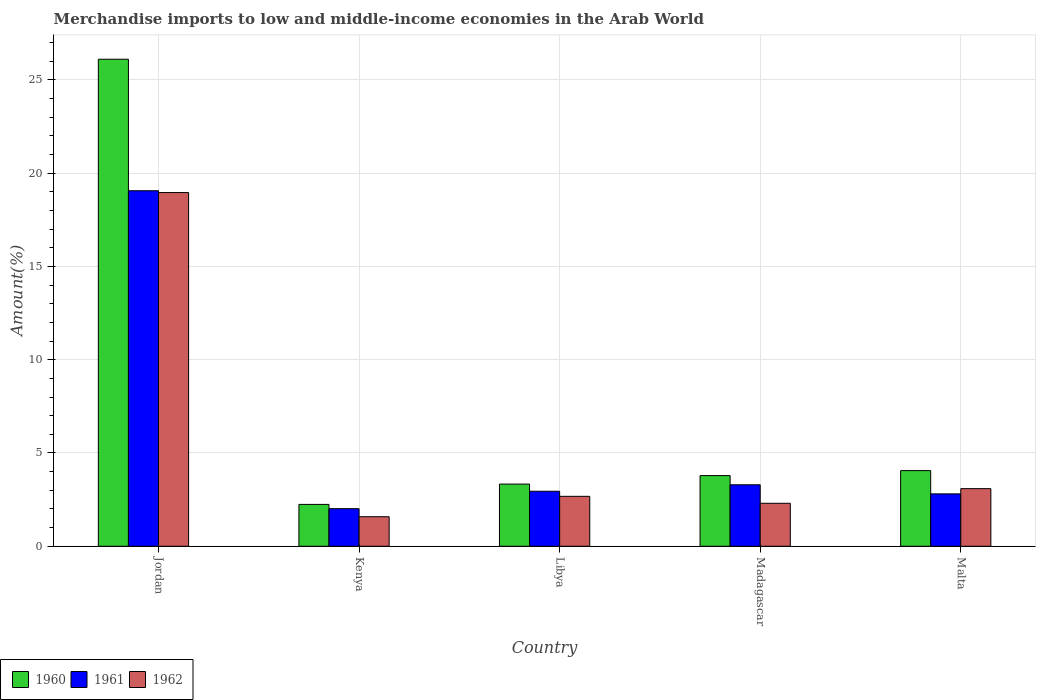Are the number of bars per tick equal to the number of legend labels?
Make the answer very short. Yes. Are the number of bars on each tick of the X-axis equal?
Your response must be concise. Yes. What is the label of the 3rd group of bars from the left?
Offer a very short reply. Libya. In how many cases, is the number of bars for a given country not equal to the number of legend labels?
Make the answer very short. 0. What is the percentage of amount earned from merchandise imports in 1961 in Madagascar?
Offer a terse response. 3.29. Across all countries, what is the maximum percentage of amount earned from merchandise imports in 1961?
Provide a short and direct response. 19.06. Across all countries, what is the minimum percentage of amount earned from merchandise imports in 1962?
Keep it short and to the point. 1.58. In which country was the percentage of amount earned from merchandise imports in 1960 maximum?
Your answer should be compact. Jordan. In which country was the percentage of amount earned from merchandise imports in 1960 minimum?
Provide a short and direct response. Kenya. What is the total percentage of amount earned from merchandise imports in 1962 in the graph?
Your response must be concise. 28.61. What is the difference between the percentage of amount earned from merchandise imports in 1962 in Madagascar and that in Malta?
Your answer should be very brief. -0.78. What is the difference between the percentage of amount earned from merchandise imports in 1962 in Malta and the percentage of amount earned from merchandise imports in 1961 in Jordan?
Give a very brief answer. -15.97. What is the average percentage of amount earned from merchandise imports in 1960 per country?
Your answer should be very brief. 7.9. What is the difference between the percentage of amount earned from merchandise imports of/in 1960 and percentage of amount earned from merchandise imports of/in 1961 in Kenya?
Ensure brevity in your answer.  0.23. What is the ratio of the percentage of amount earned from merchandise imports in 1961 in Jordan to that in Kenya?
Keep it short and to the point. 9.46. Is the difference between the percentage of amount earned from merchandise imports in 1960 in Madagascar and Malta greater than the difference between the percentage of amount earned from merchandise imports in 1961 in Madagascar and Malta?
Ensure brevity in your answer.  No. What is the difference between the highest and the second highest percentage of amount earned from merchandise imports in 1961?
Your answer should be very brief. 0.35. What is the difference between the highest and the lowest percentage of amount earned from merchandise imports in 1960?
Keep it short and to the point. 23.86. How many countries are there in the graph?
Your answer should be compact. 5. Does the graph contain grids?
Offer a terse response. Yes. Where does the legend appear in the graph?
Your answer should be compact. Bottom left. How are the legend labels stacked?
Provide a succinct answer. Horizontal. What is the title of the graph?
Offer a very short reply. Merchandise imports to low and middle-income economies in the Arab World. Does "1976" appear as one of the legend labels in the graph?
Provide a short and direct response. No. What is the label or title of the Y-axis?
Your response must be concise. Amount(%). What is the Amount(%) of 1960 in Jordan?
Give a very brief answer. 26.11. What is the Amount(%) of 1961 in Jordan?
Offer a terse response. 19.06. What is the Amount(%) in 1962 in Jordan?
Your answer should be very brief. 18.96. What is the Amount(%) of 1960 in Kenya?
Your response must be concise. 2.24. What is the Amount(%) of 1961 in Kenya?
Keep it short and to the point. 2.01. What is the Amount(%) in 1962 in Kenya?
Offer a very short reply. 1.58. What is the Amount(%) in 1960 in Libya?
Your answer should be very brief. 3.33. What is the Amount(%) in 1961 in Libya?
Your response must be concise. 2.95. What is the Amount(%) of 1962 in Libya?
Offer a terse response. 2.68. What is the Amount(%) in 1960 in Madagascar?
Give a very brief answer. 3.79. What is the Amount(%) of 1961 in Madagascar?
Offer a very short reply. 3.29. What is the Amount(%) in 1962 in Madagascar?
Provide a short and direct response. 2.3. What is the Amount(%) in 1960 in Malta?
Keep it short and to the point. 4.06. What is the Amount(%) of 1961 in Malta?
Ensure brevity in your answer.  2.81. What is the Amount(%) of 1962 in Malta?
Offer a very short reply. 3.09. Across all countries, what is the maximum Amount(%) of 1960?
Keep it short and to the point. 26.11. Across all countries, what is the maximum Amount(%) in 1961?
Your response must be concise. 19.06. Across all countries, what is the maximum Amount(%) of 1962?
Your answer should be very brief. 18.96. Across all countries, what is the minimum Amount(%) of 1960?
Your answer should be compact. 2.24. Across all countries, what is the minimum Amount(%) in 1961?
Offer a terse response. 2.01. Across all countries, what is the minimum Amount(%) of 1962?
Your answer should be compact. 1.58. What is the total Amount(%) in 1960 in the graph?
Provide a succinct answer. 39.52. What is the total Amount(%) in 1961 in the graph?
Provide a succinct answer. 30.12. What is the total Amount(%) in 1962 in the graph?
Keep it short and to the point. 28.61. What is the difference between the Amount(%) in 1960 in Jordan and that in Kenya?
Make the answer very short. 23.86. What is the difference between the Amount(%) of 1961 in Jordan and that in Kenya?
Provide a short and direct response. 17.04. What is the difference between the Amount(%) in 1962 in Jordan and that in Kenya?
Keep it short and to the point. 17.37. What is the difference between the Amount(%) of 1960 in Jordan and that in Libya?
Your response must be concise. 22.77. What is the difference between the Amount(%) in 1961 in Jordan and that in Libya?
Ensure brevity in your answer.  16.11. What is the difference between the Amount(%) of 1962 in Jordan and that in Libya?
Your response must be concise. 16.28. What is the difference between the Amount(%) in 1960 in Jordan and that in Madagascar?
Your response must be concise. 22.32. What is the difference between the Amount(%) of 1961 in Jordan and that in Madagascar?
Your response must be concise. 15.76. What is the difference between the Amount(%) in 1962 in Jordan and that in Madagascar?
Your answer should be compact. 16.65. What is the difference between the Amount(%) in 1960 in Jordan and that in Malta?
Offer a terse response. 22.05. What is the difference between the Amount(%) of 1961 in Jordan and that in Malta?
Provide a short and direct response. 16.25. What is the difference between the Amount(%) of 1962 in Jordan and that in Malta?
Offer a very short reply. 15.87. What is the difference between the Amount(%) in 1960 in Kenya and that in Libya?
Ensure brevity in your answer.  -1.09. What is the difference between the Amount(%) in 1961 in Kenya and that in Libya?
Your response must be concise. -0.94. What is the difference between the Amount(%) in 1962 in Kenya and that in Libya?
Offer a very short reply. -1.09. What is the difference between the Amount(%) of 1960 in Kenya and that in Madagascar?
Offer a very short reply. -1.54. What is the difference between the Amount(%) of 1961 in Kenya and that in Madagascar?
Offer a very short reply. -1.28. What is the difference between the Amount(%) in 1962 in Kenya and that in Madagascar?
Offer a terse response. -0.72. What is the difference between the Amount(%) in 1960 in Kenya and that in Malta?
Your answer should be compact. -1.81. What is the difference between the Amount(%) in 1961 in Kenya and that in Malta?
Ensure brevity in your answer.  -0.79. What is the difference between the Amount(%) in 1962 in Kenya and that in Malta?
Offer a terse response. -1.5. What is the difference between the Amount(%) of 1960 in Libya and that in Madagascar?
Provide a succinct answer. -0.45. What is the difference between the Amount(%) in 1961 in Libya and that in Madagascar?
Your answer should be very brief. -0.35. What is the difference between the Amount(%) of 1962 in Libya and that in Madagascar?
Your answer should be very brief. 0.37. What is the difference between the Amount(%) in 1960 in Libya and that in Malta?
Your answer should be very brief. -0.72. What is the difference between the Amount(%) in 1961 in Libya and that in Malta?
Your answer should be very brief. 0.14. What is the difference between the Amount(%) of 1962 in Libya and that in Malta?
Your answer should be compact. -0.41. What is the difference between the Amount(%) in 1960 in Madagascar and that in Malta?
Your answer should be very brief. -0.27. What is the difference between the Amount(%) of 1961 in Madagascar and that in Malta?
Give a very brief answer. 0.49. What is the difference between the Amount(%) of 1962 in Madagascar and that in Malta?
Provide a succinct answer. -0.79. What is the difference between the Amount(%) in 1960 in Jordan and the Amount(%) in 1961 in Kenya?
Provide a succinct answer. 24.09. What is the difference between the Amount(%) of 1960 in Jordan and the Amount(%) of 1962 in Kenya?
Provide a short and direct response. 24.52. What is the difference between the Amount(%) in 1961 in Jordan and the Amount(%) in 1962 in Kenya?
Your answer should be compact. 17.47. What is the difference between the Amount(%) of 1960 in Jordan and the Amount(%) of 1961 in Libya?
Your answer should be very brief. 23.16. What is the difference between the Amount(%) in 1960 in Jordan and the Amount(%) in 1962 in Libya?
Keep it short and to the point. 23.43. What is the difference between the Amount(%) in 1961 in Jordan and the Amount(%) in 1962 in Libya?
Provide a succinct answer. 16.38. What is the difference between the Amount(%) in 1960 in Jordan and the Amount(%) in 1961 in Madagascar?
Your answer should be compact. 22.81. What is the difference between the Amount(%) in 1960 in Jordan and the Amount(%) in 1962 in Madagascar?
Offer a very short reply. 23.8. What is the difference between the Amount(%) in 1961 in Jordan and the Amount(%) in 1962 in Madagascar?
Make the answer very short. 16.75. What is the difference between the Amount(%) of 1960 in Jordan and the Amount(%) of 1961 in Malta?
Make the answer very short. 23.3. What is the difference between the Amount(%) in 1960 in Jordan and the Amount(%) in 1962 in Malta?
Offer a terse response. 23.02. What is the difference between the Amount(%) of 1961 in Jordan and the Amount(%) of 1962 in Malta?
Make the answer very short. 15.97. What is the difference between the Amount(%) in 1960 in Kenya and the Amount(%) in 1961 in Libya?
Provide a succinct answer. -0.71. What is the difference between the Amount(%) of 1960 in Kenya and the Amount(%) of 1962 in Libya?
Provide a short and direct response. -0.43. What is the difference between the Amount(%) of 1961 in Kenya and the Amount(%) of 1962 in Libya?
Provide a short and direct response. -0.66. What is the difference between the Amount(%) in 1960 in Kenya and the Amount(%) in 1961 in Madagascar?
Provide a succinct answer. -1.05. What is the difference between the Amount(%) in 1960 in Kenya and the Amount(%) in 1962 in Madagascar?
Ensure brevity in your answer.  -0.06. What is the difference between the Amount(%) of 1961 in Kenya and the Amount(%) of 1962 in Madagascar?
Offer a very short reply. -0.29. What is the difference between the Amount(%) of 1960 in Kenya and the Amount(%) of 1961 in Malta?
Provide a succinct answer. -0.56. What is the difference between the Amount(%) in 1960 in Kenya and the Amount(%) in 1962 in Malta?
Provide a succinct answer. -0.84. What is the difference between the Amount(%) of 1961 in Kenya and the Amount(%) of 1962 in Malta?
Offer a very short reply. -1.07. What is the difference between the Amount(%) in 1960 in Libya and the Amount(%) in 1961 in Madagascar?
Provide a short and direct response. 0.04. What is the difference between the Amount(%) in 1960 in Libya and the Amount(%) in 1962 in Madagascar?
Your answer should be very brief. 1.03. What is the difference between the Amount(%) of 1961 in Libya and the Amount(%) of 1962 in Madagascar?
Your response must be concise. 0.65. What is the difference between the Amount(%) in 1960 in Libya and the Amount(%) in 1961 in Malta?
Make the answer very short. 0.53. What is the difference between the Amount(%) of 1960 in Libya and the Amount(%) of 1962 in Malta?
Offer a very short reply. 0.25. What is the difference between the Amount(%) of 1961 in Libya and the Amount(%) of 1962 in Malta?
Provide a short and direct response. -0.14. What is the difference between the Amount(%) in 1960 in Madagascar and the Amount(%) in 1961 in Malta?
Offer a very short reply. 0.98. What is the difference between the Amount(%) in 1960 in Madagascar and the Amount(%) in 1962 in Malta?
Keep it short and to the point. 0.7. What is the difference between the Amount(%) of 1961 in Madagascar and the Amount(%) of 1962 in Malta?
Keep it short and to the point. 0.21. What is the average Amount(%) in 1960 per country?
Your answer should be very brief. 7.9. What is the average Amount(%) of 1961 per country?
Your answer should be very brief. 6.02. What is the average Amount(%) in 1962 per country?
Provide a succinct answer. 5.72. What is the difference between the Amount(%) in 1960 and Amount(%) in 1961 in Jordan?
Provide a succinct answer. 7.05. What is the difference between the Amount(%) of 1960 and Amount(%) of 1962 in Jordan?
Provide a short and direct response. 7.15. What is the difference between the Amount(%) in 1961 and Amount(%) in 1962 in Jordan?
Offer a terse response. 0.1. What is the difference between the Amount(%) of 1960 and Amount(%) of 1961 in Kenya?
Provide a short and direct response. 0.23. What is the difference between the Amount(%) in 1960 and Amount(%) in 1962 in Kenya?
Your response must be concise. 0.66. What is the difference between the Amount(%) in 1961 and Amount(%) in 1962 in Kenya?
Provide a short and direct response. 0.43. What is the difference between the Amount(%) of 1960 and Amount(%) of 1961 in Libya?
Ensure brevity in your answer.  0.38. What is the difference between the Amount(%) in 1960 and Amount(%) in 1962 in Libya?
Your response must be concise. 0.66. What is the difference between the Amount(%) in 1961 and Amount(%) in 1962 in Libya?
Provide a succinct answer. 0.27. What is the difference between the Amount(%) of 1960 and Amount(%) of 1961 in Madagascar?
Your answer should be very brief. 0.49. What is the difference between the Amount(%) in 1960 and Amount(%) in 1962 in Madagascar?
Your answer should be very brief. 1.48. What is the difference between the Amount(%) in 1961 and Amount(%) in 1962 in Madagascar?
Offer a very short reply. 0.99. What is the difference between the Amount(%) in 1960 and Amount(%) in 1961 in Malta?
Ensure brevity in your answer.  1.25. What is the difference between the Amount(%) in 1960 and Amount(%) in 1962 in Malta?
Make the answer very short. 0.97. What is the difference between the Amount(%) of 1961 and Amount(%) of 1962 in Malta?
Your answer should be compact. -0.28. What is the ratio of the Amount(%) of 1960 in Jordan to that in Kenya?
Offer a very short reply. 11.64. What is the ratio of the Amount(%) in 1961 in Jordan to that in Kenya?
Keep it short and to the point. 9.46. What is the ratio of the Amount(%) of 1962 in Jordan to that in Kenya?
Make the answer very short. 11.98. What is the ratio of the Amount(%) of 1960 in Jordan to that in Libya?
Offer a very short reply. 7.83. What is the ratio of the Amount(%) of 1961 in Jordan to that in Libya?
Give a very brief answer. 6.46. What is the ratio of the Amount(%) of 1962 in Jordan to that in Libya?
Keep it short and to the point. 7.09. What is the ratio of the Amount(%) in 1960 in Jordan to that in Madagascar?
Your answer should be compact. 6.89. What is the ratio of the Amount(%) in 1961 in Jordan to that in Madagascar?
Keep it short and to the point. 5.78. What is the ratio of the Amount(%) of 1962 in Jordan to that in Madagascar?
Give a very brief answer. 8.23. What is the ratio of the Amount(%) in 1960 in Jordan to that in Malta?
Give a very brief answer. 6.44. What is the ratio of the Amount(%) in 1961 in Jordan to that in Malta?
Your answer should be compact. 6.79. What is the ratio of the Amount(%) of 1962 in Jordan to that in Malta?
Ensure brevity in your answer.  6.14. What is the ratio of the Amount(%) of 1960 in Kenya to that in Libya?
Offer a very short reply. 0.67. What is the ratio of the Amount(%) in 1961 in Kenya to that in Libya?
Make the answer very short. 0.68. What is the ratio of the Amount(%) of 1962 in Kenya to that in Libya?
Provide a short and direct response. 0.59. What is the ratio of the Amount(%) in 1960 in Kenya to that in Madagascar?
Ensure brevity in your answer.  0.59. What is the ratio of the Amount(%) in 1961 in Kenya to that in Madagascar?
Give a very brief answer. 0.61. What is the ratio of the Amount(%) of 1962 in Kenya to that in Madagascar?
Make the answer very short. 0.69. What is the ratio of the Amount(%) of 1960 in Kenya to that in Malta?
Ensure brevity in your answer.  0.55. What is the ratio of the Amount(%) in 1961 in Kenya to that in Malta?
Offer a terse response. 0.72. What is the ratio of the Amount(%) in 1962 in Kenya to that in Malta?
Your response must be concise. 0.51. What is the ratio of the Amount(%) of 1960 in Libya to that in Madagascar?
Provide a short and direct response. 0.88. What is the ratio of the Amount(%) of 1961 in Libya to that in Madagascar?
Make the answer very short. 0.9. What is the ratio of the Amount(%) in 1962 in Libya to that in Madagascar?
Keep it short and to the point. 1.16. What is the ratio of the Amount(%) of 1960 in Libya to that in Malta?
Ensure brevity in your answer.  0.82. What is the ratio of the Amount(%) in 1961 in Libya to that in Malta?
Make the answer very short. 1.05. What is the ratio of the Amount(%) in 1962 in Libya to that in Malta?
Your answer should be compact. 0.87. What is the ratio of the Amount(%) of 1960 in Madagascar to that in Malta?
Make the answer very short. 0.93. What is the ratio of the Amount(%) of 1961 in Madagascar to that in Malta?
Your answer should be compact. 1.17. What is the ratio of the Amount(%) in 1962 in Madagascar to that in Malta?
Keep it short and to the point. 0.75. What is the difference between the highest and the second highest Amount(%) of 1960?
Your response must be concise. 22.05. What is the difference between the highest and the second highest Amount(%) in 1961?
Offer a terse response. 15.76. What is the difference between the highest and the second highest Amount(%) in 1962?
Provide a short and direct response. 15.87. What is the difference between the highest and the lowest Amount(%) of 1960?
Your response must be concise. 23.86. What is the difference between the highest and the lowest Amount(%) in 1961?
Offer a terse response. 17.04. What is the difference between the highest and the lowest Amount(%) in 1962?
Your response must be concise. 17.37. 